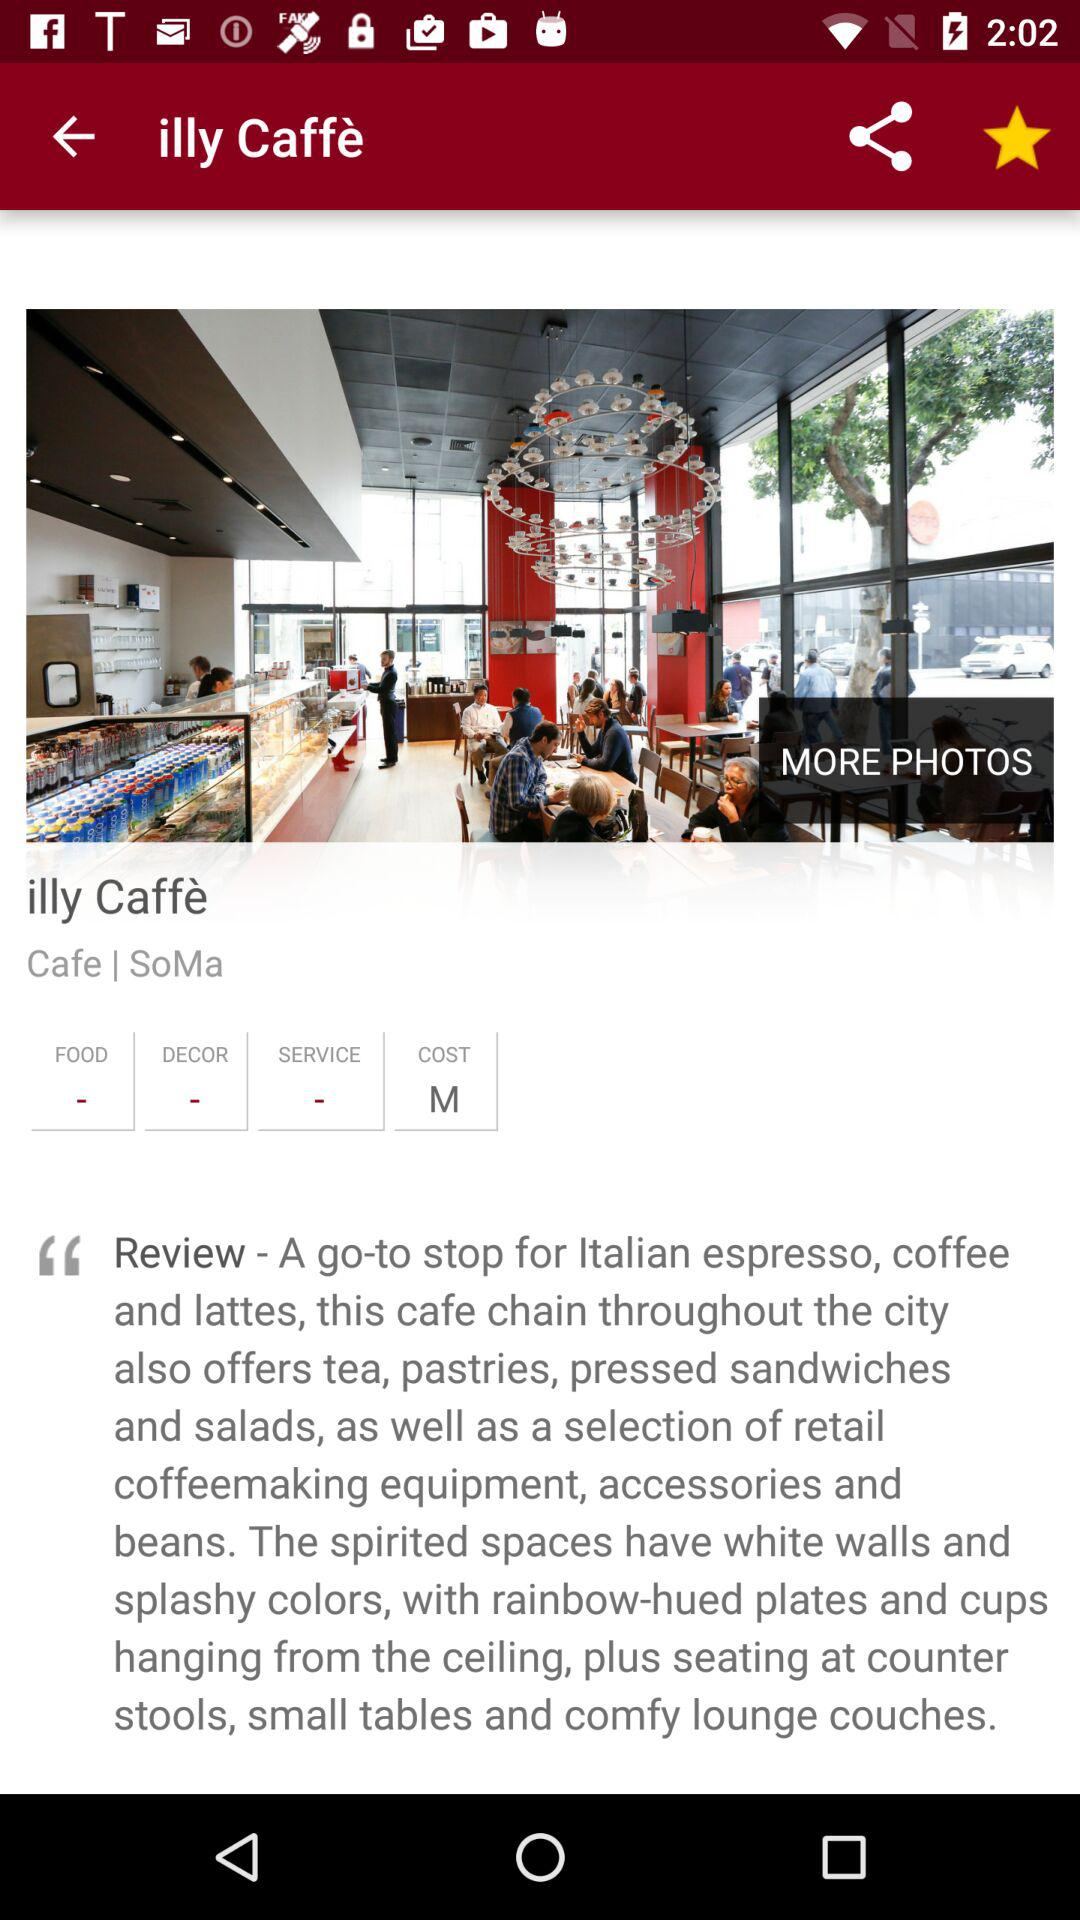What is the cafe name? The cafe name is "illy Caffè". 